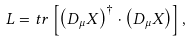Convert formula to latex. <formula><loc_0><loc_0><loc_500><loc_500>L = t r \left [ \left ( D _ { \mu } X \right ) ^ { \dagger } \cdot \left ( D _ { \mu } X \right ) \right ] ,</formula> 